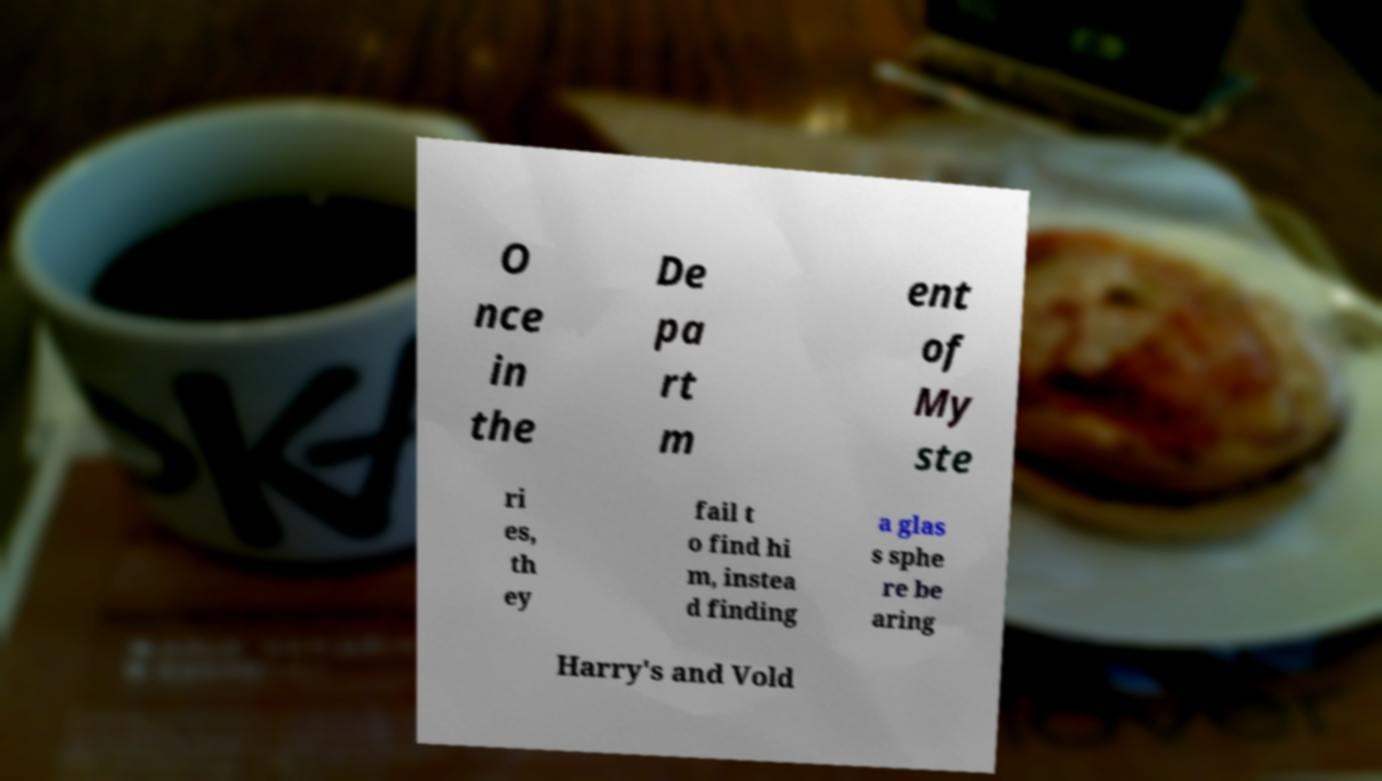Can you read and provide the text displayed in the image?This photo seems to have some interesting text. Can you extract and type it out for me? O nce in the De pa rt m ent of My ste ri es, th ey fail t o find hi m, instea d finding a glas s sphe re be aring Harry's and Vold 